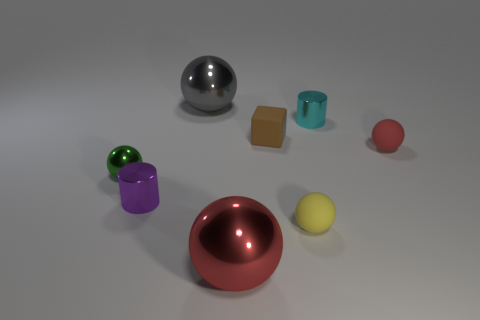What number of small things are both right of the green sphere and in front of the small cyan cylinder?
Your response must be concise. 4. The tiny shiny cylinder left of the ball behind the red ball behind the red metal object is what color?
Your answer should be compact. Purple. What number of green spheres are behind the large ball that is in front of the small purple metallic cylinder?
Offer a very short reply. 1. What number of other objects are there of the same shape as the large red metal thing?
Offer a very short reply. 4. What number of objects are either rubber balls or small things in front of the purple cylinder?
Give a very brief answer. 2. Is the number of tiny matte balls left of the brown rubber object greater than the number of purple metal cylinders that are left of the purple metallic thing?
Keep it short and to the point. No. What shape is the small shiny object that is behind the red matte object behind the large metal thing that is in front of the gray thing?
Your response must be concise. Cylinder. What shape is the tiny rubber thing that is in front of the metallic sphere that is to the left of the tiny purple shiny cylinder?
Your answer should be very brief. Sphere. Are there any other objects that have the same material as the tiny red object?
Keep it short and to the point. Yes. How many yellow things are either small matte cylinders or small rubber balls?
Your answer should be very brief. 1. 